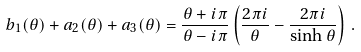<formula> <loc_0><loc_0><loc_500><loc_500>b _ { 1 } ( \theta ) + a _ { 2 } ( \theta ) + a _ { 3 } ( \theta ) = \frac { \theta + i \pi } { \theta - i \pi } \left ( \frac { 2 \pi i } { \theta } - \frac { 2 \pi i } { \sinh \theta } \right ) \, .</formula> 